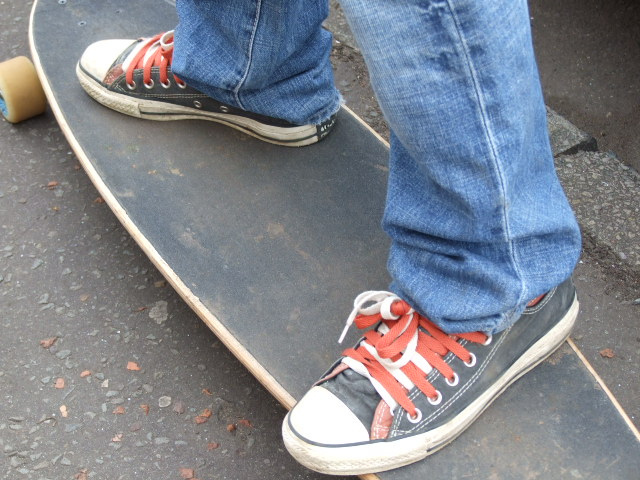Can you tell me what activity this footwear is commonly associated with? This style of sneaker is commonly associated with casual wear and has a strong cultural connection to skateboarding and street style due to its durable design and grip. What's remarkable about the color scheme of these shoes? The striking red laces on these black Converse sneakers create a bold contrast that is both eye-catching and stylish. The color scheme adds a pop of color to the classic shoe design, giving it a personalized and edgy look. 